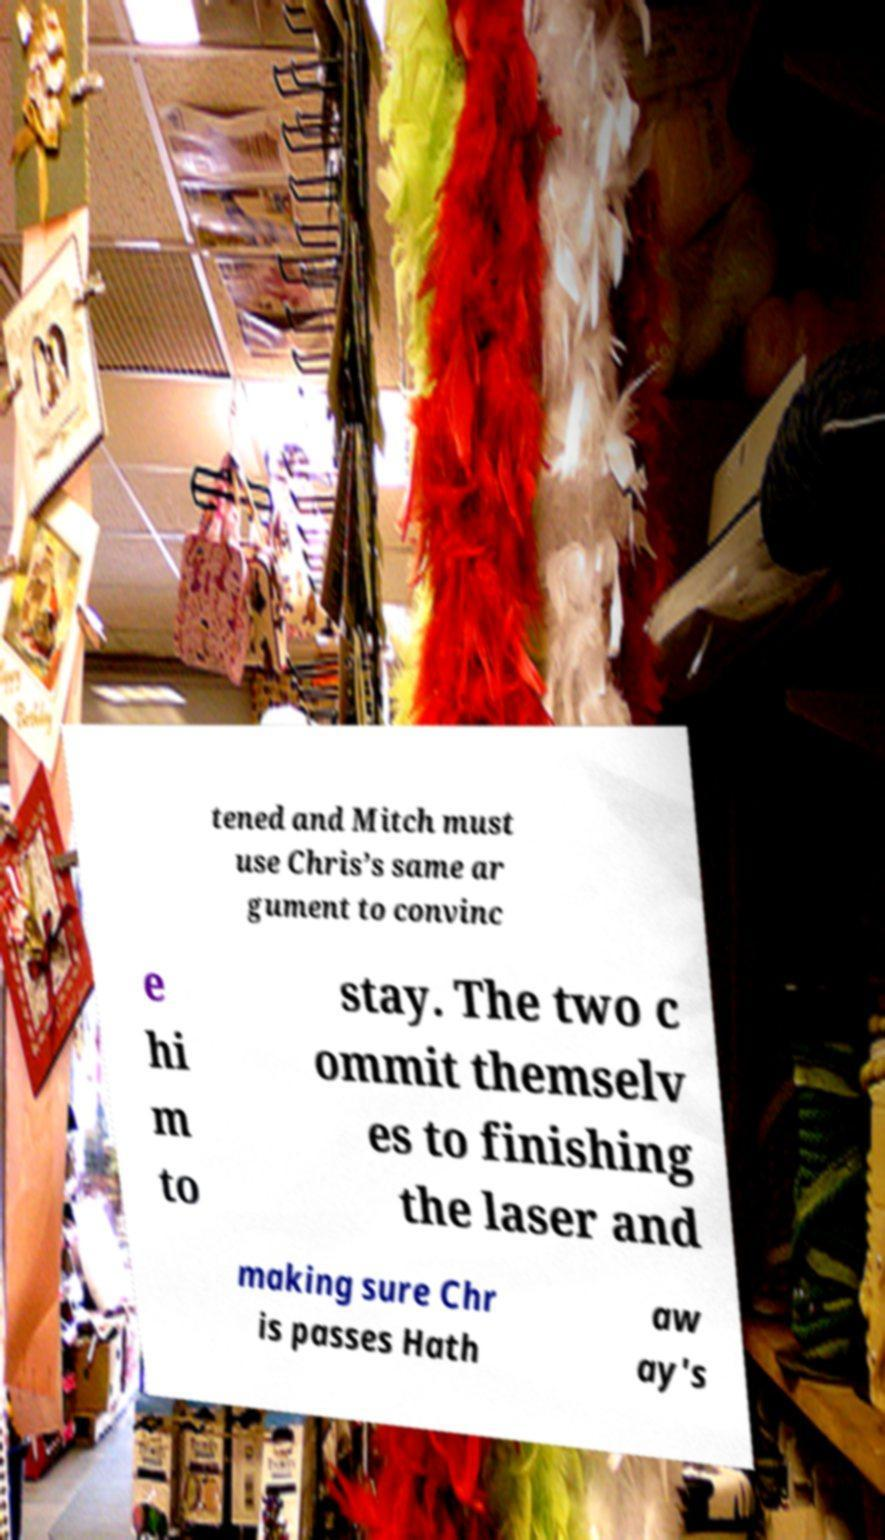What messages or text are displayed in this image? I need them in a readable, typed format. tened and Mitch must use Chris’s same ar gument to convinc e hi m to stay. The two c ommit themselv es to finishing the laser and making sure Chr is passes Hath aw ay's 